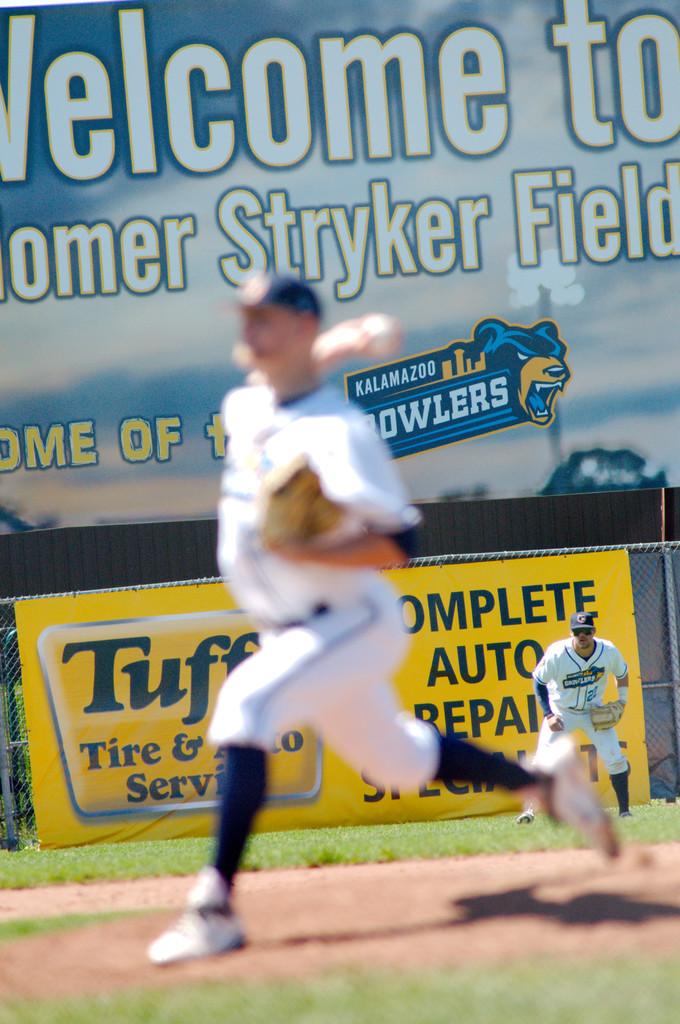What is the name of the team?
Your answer should be very brief. Howlers. 